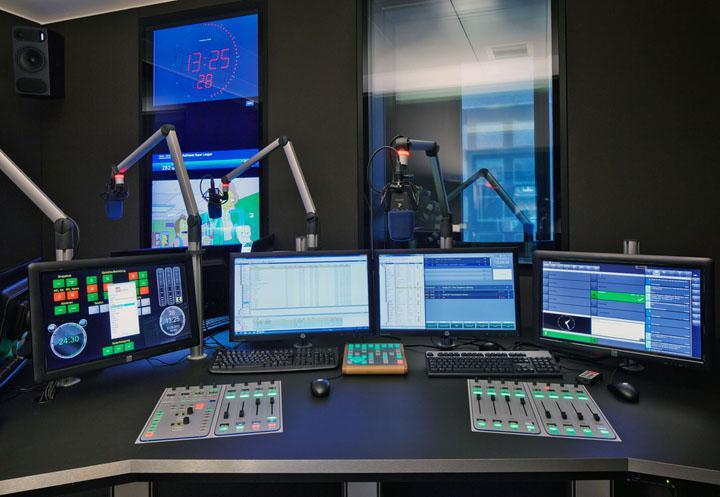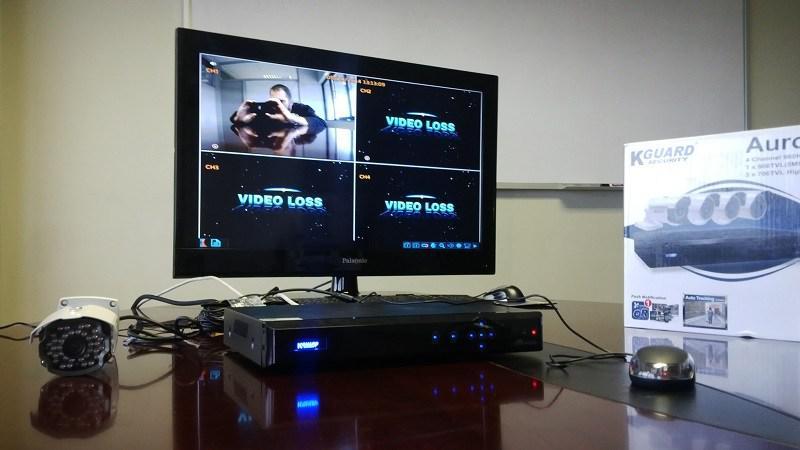The first image is the image on the left, the second image is the image on the right. Considering the images on both sides, is "The right image shows a seated person in the center, facing cameras." valid? Answer yes or no. No. 